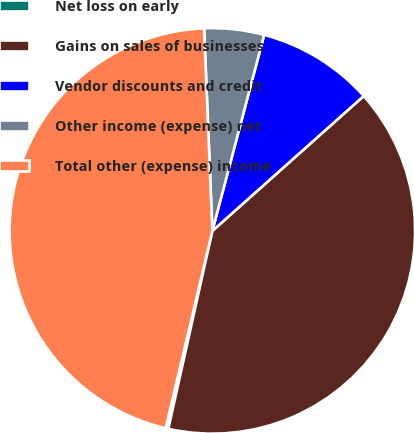<chart> <loc_0><loc_0><loc_500><loc_500><pie_chart><fcel>Net loss on early<fcel>Gains on sales of businesses<fcel>Vendor discounts and credit<fcel>Other income (expense) net<fcel>Total other (expense) income<nl><fcel>0.22%<fcel>40.07%<fcel>9.3%<fcel>4.76%<fcel>45.65%<nl></chart> 